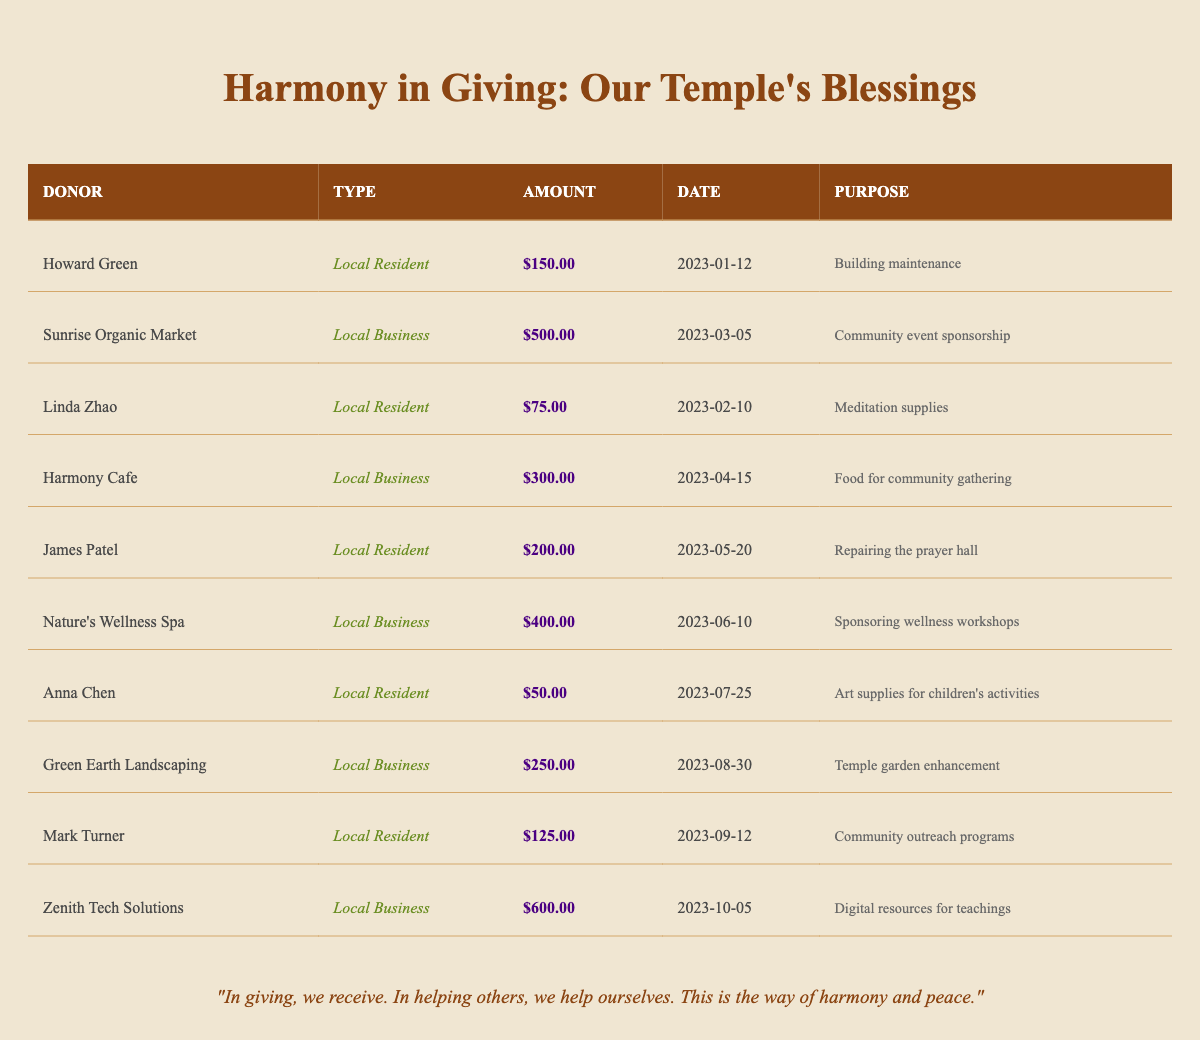What is the total amount donated by local residents? To find the total amount donated by local residents, I will sum the amounts for all entries where the donor type is "Local Resident". The amounts are $150.00 (Howard Green) + $75.00 (Linda Zhao) + $200.00 (James Patel) + $50.00 (Anna Chen) + $125.00 (Mark Turner) = $600.00
Answer: $600.00 Which local business donated the largest amount? By reviewing the amounts listed for local businesses, I identify that Sunrise Organic Market donated $500.00, Harmony Cafe donated $300.00, Nature's Wellness Spa donated $400.00, Green Earth Landscaping donated $250.00, and Zenith Tech Solutions donated $600.00. The largest amount is from Zenith Tech Solutions with $600.00.
Answer: Zenith Tech Solutions How many donations were made for community-related purposes? I will count the donations that have purposes related to community activities. The relevant donations are from Sunrise Organic Market (community event sponsorship), Harmony Cafe (food for community gathering), Anna Chen (art supplies for children’s activities), and Mark Turner (community outreach programs). This gives us a total of 4 donations.
Answer: 4 What is the average donation amount from local businesses? To calculate the average donation from local businesses, I will first sum the amounts donated by them: $500.00 (Sunrise Organic Market) + $300.00 (Harmony Cafe) + $400.00 (Nature's Wellness Spa) + $250.00 (Green Earth Landscaping) + $600.00 (Zenith Tech Solutions) = $2050.00. There are 5 business donations, so the average is $2050.00 ÷ 5 = $410.00.
Answer: $410.00 Did any donor contribute more than $500.00? I will check all the donated amounts listed in the table. The amounts are $150.00, $500.00, $75.00, $300.00, $200.00, $400.00, $50.00, $250.00, $125.00, and $600.00. Among these, $600.00 is greater than $500.00, confirming that at least one donor did contribute more.
Answer: Yes How much was collectively donated towards maintenance and repair purposes? I will sum the contributions that specifically mention maintenance and repair. The donations related to these purposes are $150.00 (building maintenance from Howard Green) and $200.00 (repairing the prayer hall from James Patel). Hence, the total is $150.00 + $200.00 = $350.00.
Answer: $350.00 Which month had the highest total donation amount? I will organize the donation amounts by month: January ($150.00), February ($75.00), March ($500.00), April ($300.00), May ($200.00), June ($400.00), July ($50.00), August ($250.00), September ($125.00), and October ($600.00). Adding these, October has the highest total of $600.00.
Answer: October What proportion of total donations came from local residents? I first calculate the total donations, which is the sum of all amounts: $150 + $500 + $75 + $300 + $200 + $400 + $50 + $250 + $125 + $600 = $2650. From the previous answer, local residents donated a total of $600.00. The proportion is $600.00 ÷ $2650.00 = approximately 0.226 or 22.6%.
Answer: 22.6% 